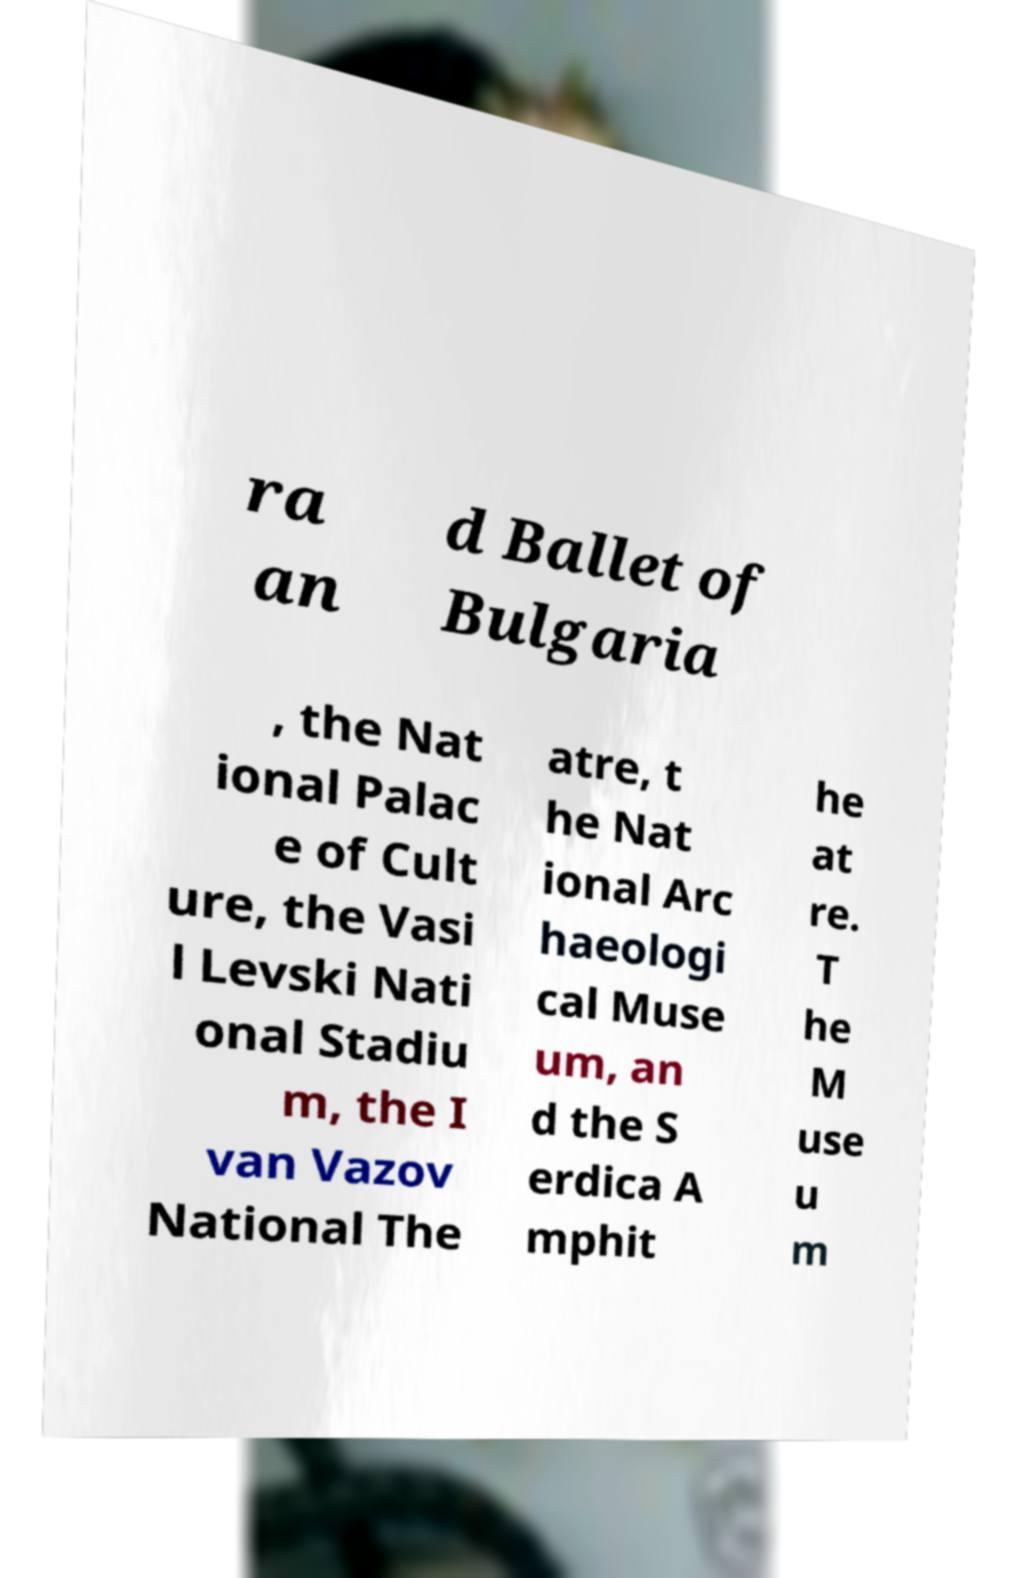Please read and relay the text visible in this image. What does it say? ra an d Ballet of Bulgaria , the Nat ional Palac e of Cult ure, the Vasi l Levski Nati onal Stadiu m, the I van Vazov National The atre, t he Nat ional Arc haeologi cal Muse um, an d the S erdica A mphit he at re. T he M use u m 